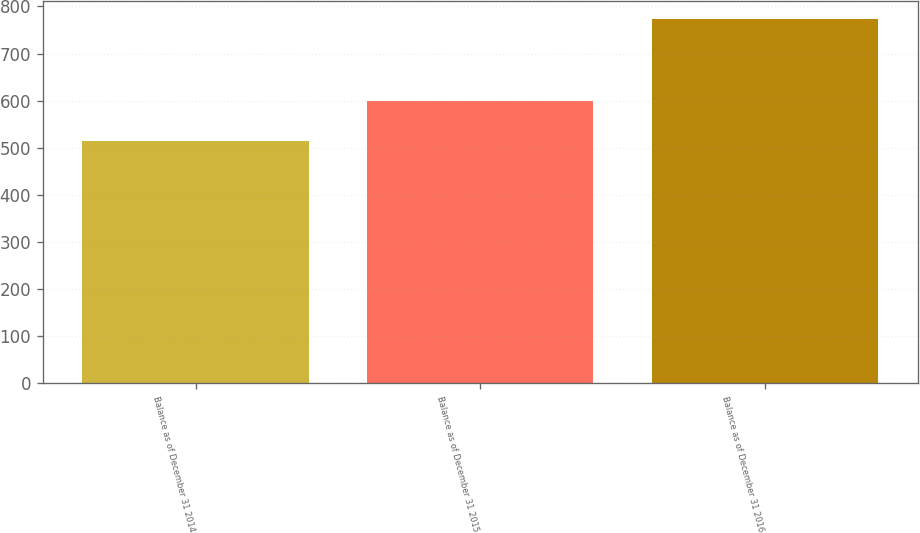<chart> <loc_0><loc_0><loc_500><loc_500><bar_chart><fcel>Balance as of December 31 2014<fcel>Balance as of December 31 2015<fcel>Balance as of December 31 2016<nl><fcel>514<fcel>600<fcel>773<nl></chart> 